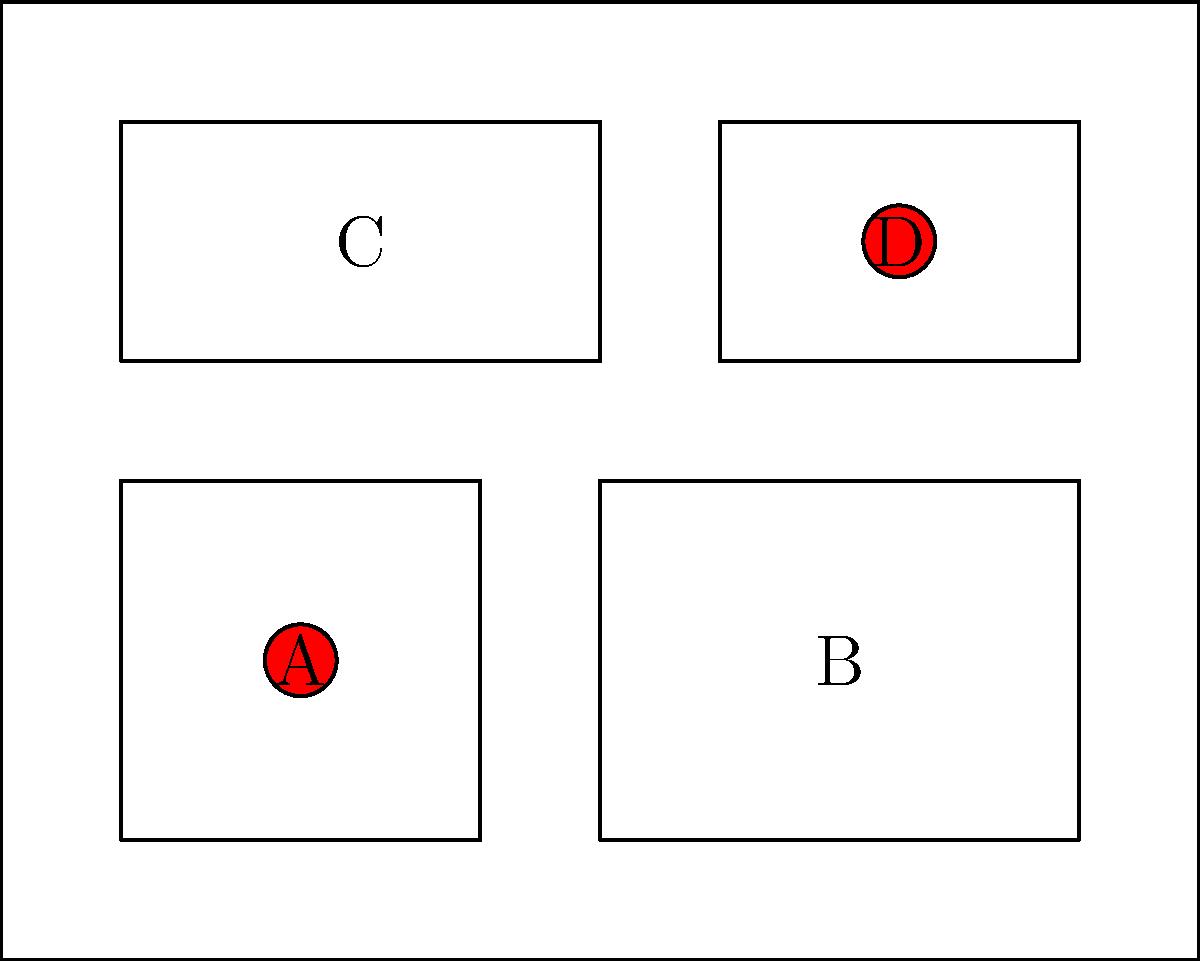Analyze the architectural blueprint of a multi-room building. Two rooms contain hidden superhero bases, marked by red circles. Which rooms house these secret facilities? To identify the rooms with secret superhero bases, we need to examine the blueprint carefully:

1. The building is divided into four distinct rooms, labeled A, B, C, and D.
2. Red circles indicate the presence of secret superhero bases.
3. Examining each room:
   - Room A (bottom-left): Contains a red circle at its center.
   - Room B (bottom-right): No red circle present.
   - Room C (top-left): No red circle present.
   - Room D (top-right): Contains a red circle at its center.
4. The red circles are located in rooms A and D.

Therefore, the secret superhero bases are housed in rooms A and D.
Answer: A and D 